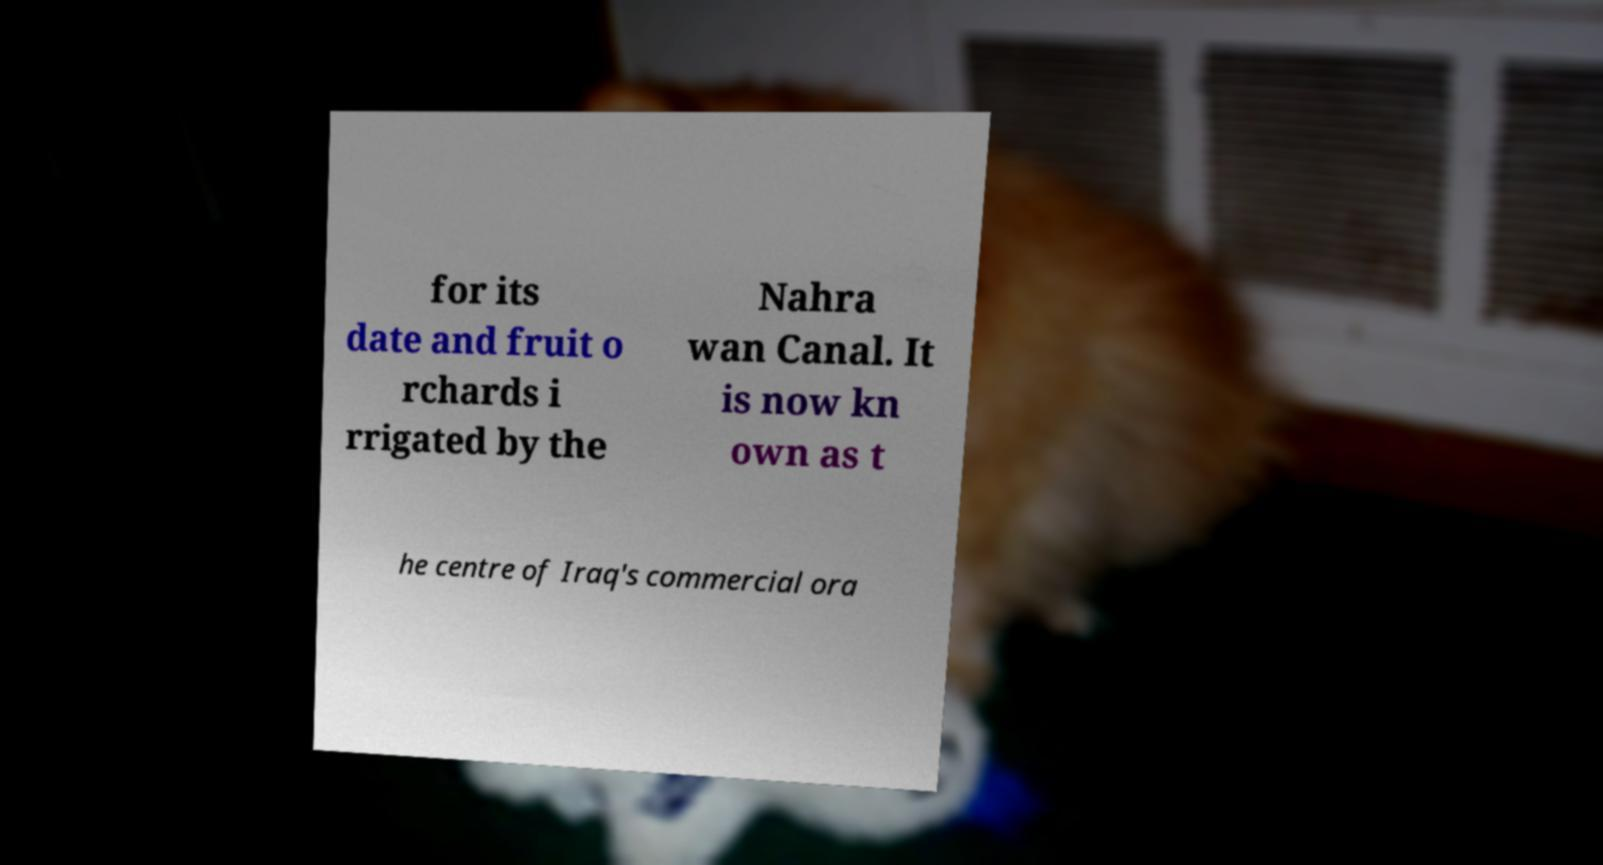Could you extract and type out the text from this image? for its date and fruit o rchards i rrigated by the Nahra wan Canal. It is now kn own as t he centre of Iraq's commercial ora 